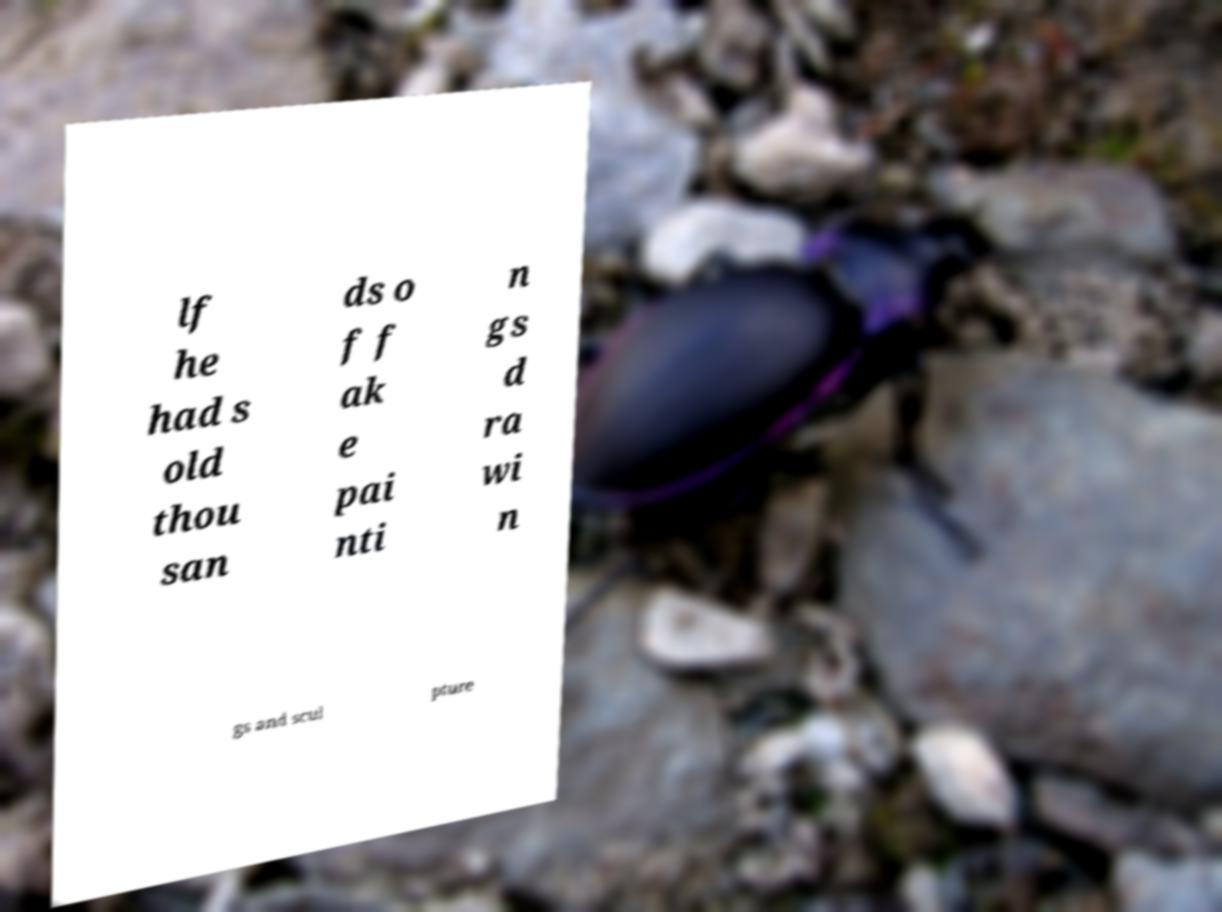For documentation purposes, I need the text within this image transcribed. Could you provide that? lf he had s old thou san ds o f f ak e pai nti n gs d ra wi n gs and scul pture 